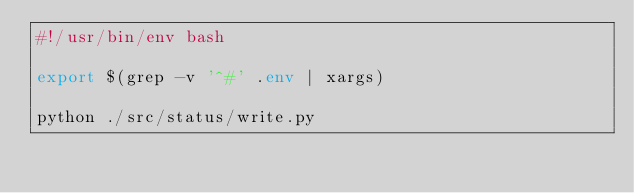Convert code to text. <code><loc_0><loc_0><loc_500><loc_500><_Bash_>#!/usr/bin/env bash

export $(grep -v '^#' .env | xargs)

python ./src/status/write.py
</code> 